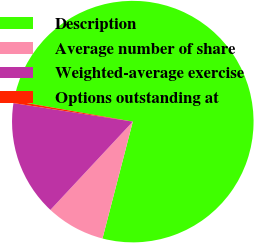Convert chart to OTSL. <chart><loc_0><loc_0><loc_500><loc_500><pie_chart><fcel>Description<fcel>Average number of share<fcel>Weighted-average exercise<fcel>Options outstanding at<nl><fcel>76.28%<fcel>7.91%<fcel>15.5%<fcel>0.31%<nl></chart> 